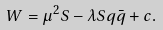Convert formula to latex. <formula><loc_0><loc_0><loc_500><loc_500>W = \mu ^ { 2 } S - \lambda S q \bar { q } + c .</formula> 